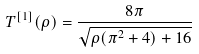<formula> <loc_0><loc_0><loc_500><loc_500>T ^ { [ 1 ] } ( \rho ) = \frac { 8 \pi } { \sqrt { \rho ( \pi ^ { 2 } + 4 ) + 1 6 } }</formula> 